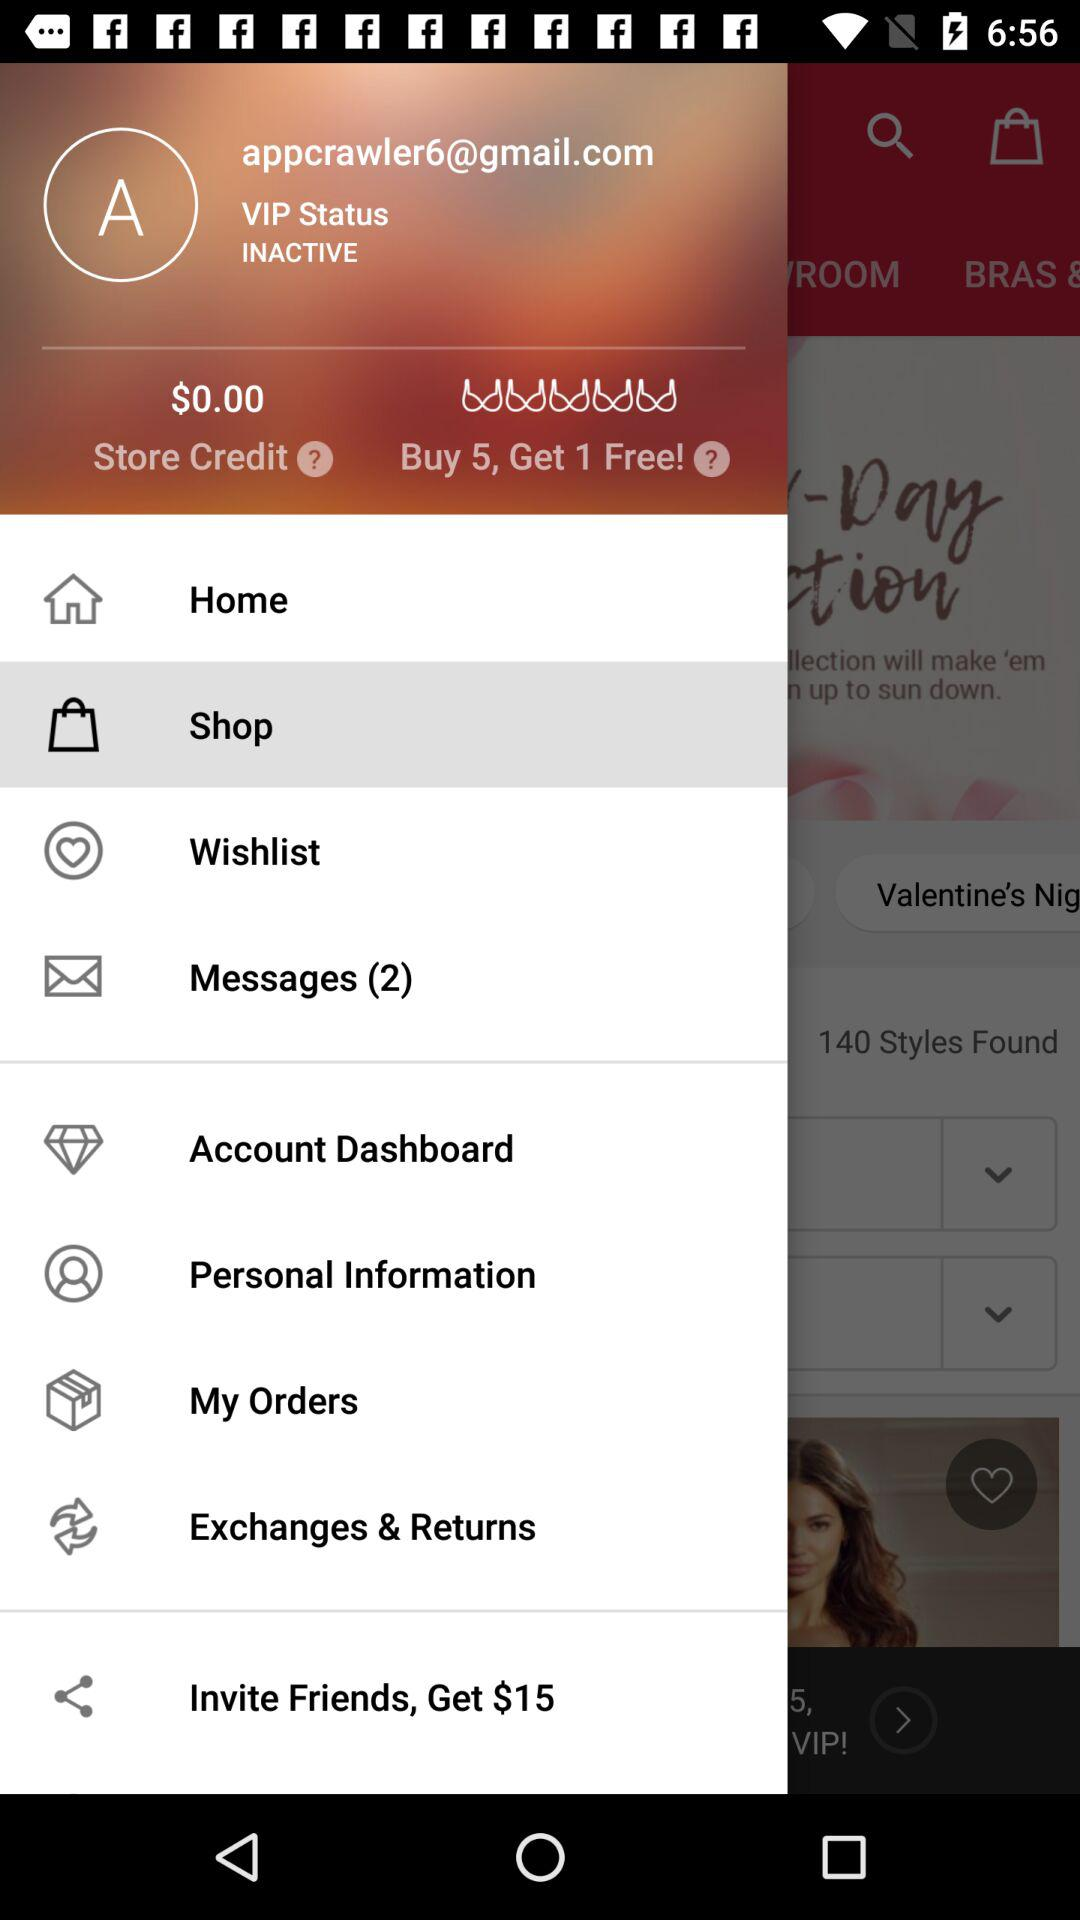How much money is in the store credit?
Answer the question using a single word or phrase. $0.00 